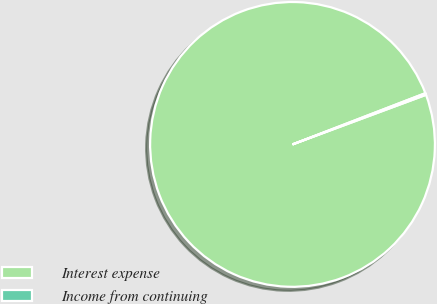<chart> <loc_0><loc_0><loc_500><loc_500><pie_chart><fcel>Interest expense<fcel>Income from continuing<nl><fcel>99.8%<fcel>0.2%<nl></chart> 